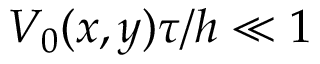<formula> <loc_0><loc_0><loc_500><loc_500>V _ { 0 } ( x , y ) \tau / h \ll 1</formula> 